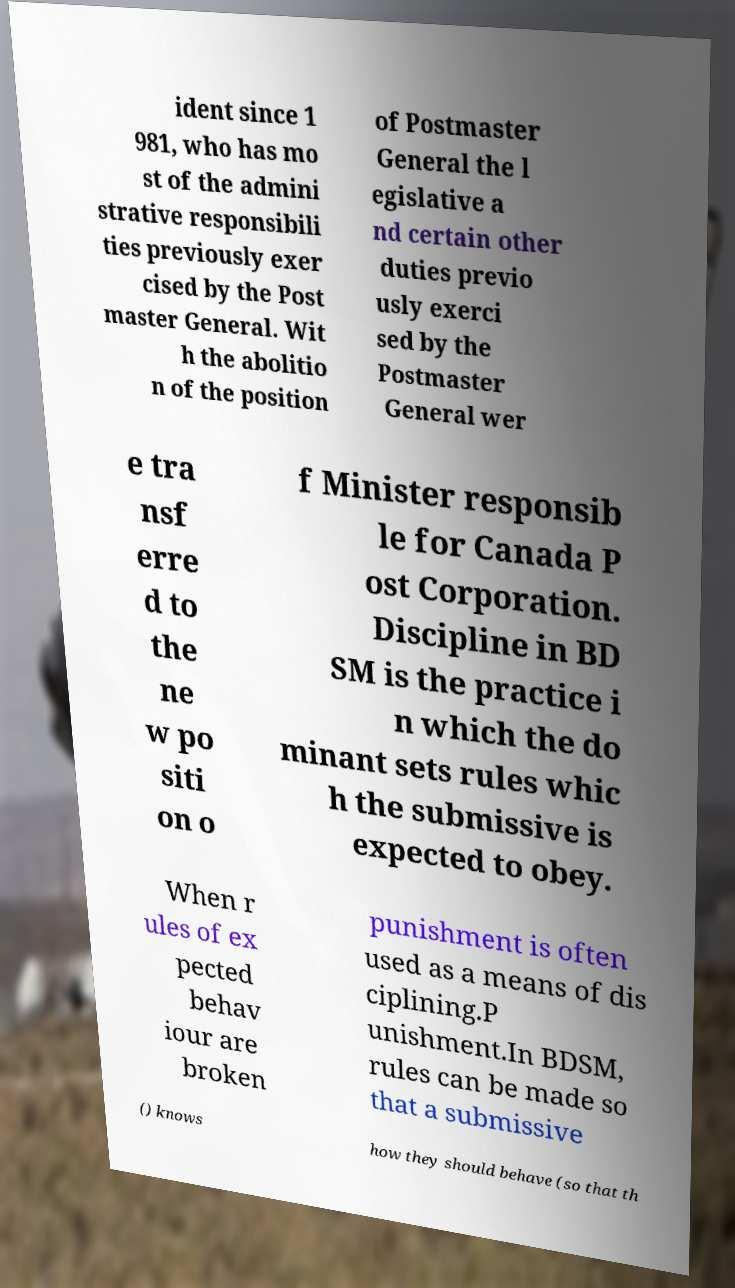For documentation purposes, I need the text within this image transcribed. Could you provide that? ident since 1 981, who has mo st of the admini strative responsibili ties previously exer cised by the Post master General. Wit h the abolitio n of the position of Postmaster General the l egislative a nd certain other duties previo usly exerci sed by the Postmaster General wer e tra nsf erre d to the ne w po siti on o f Minister responsib le for Canada P ost Corporation. Discipline in BD SM is the practice i n which the do minant sets rules whic h the submissive is expected to obey. When r ules of ex pected behav iour are broken punishment is often used as a means of dis ciplining.P unishment.In BDSM, rules can be made so that a submissive () knows how they should behave (so that th 